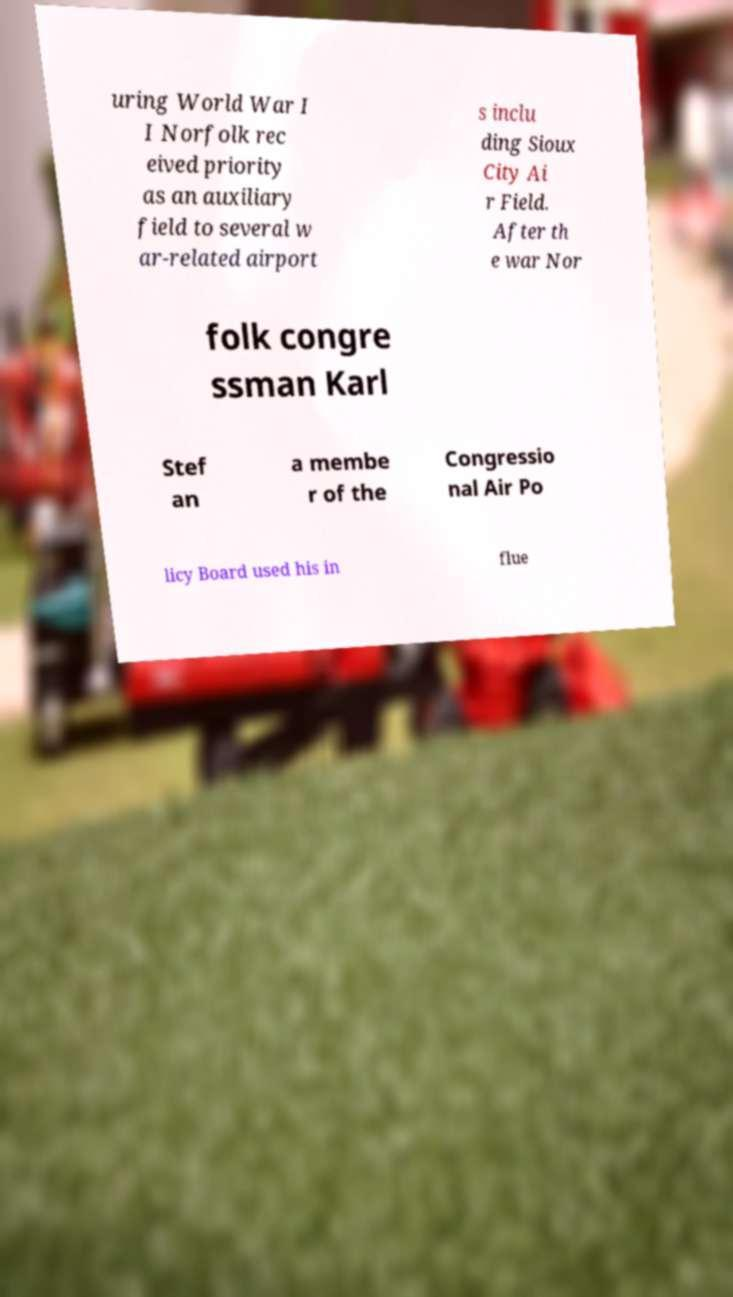Could you assist in decoding the text presented in this image and type it out clearly? uring World War I I Norfolk rec eived priority as an auxiliary field to several w ar-related airport s inclu ding Sioux City Ai r Field. After th e war Nor folk congre ssman Karl Stef an a membe r of the Congressio nal Air Po licy Board used his in flue 